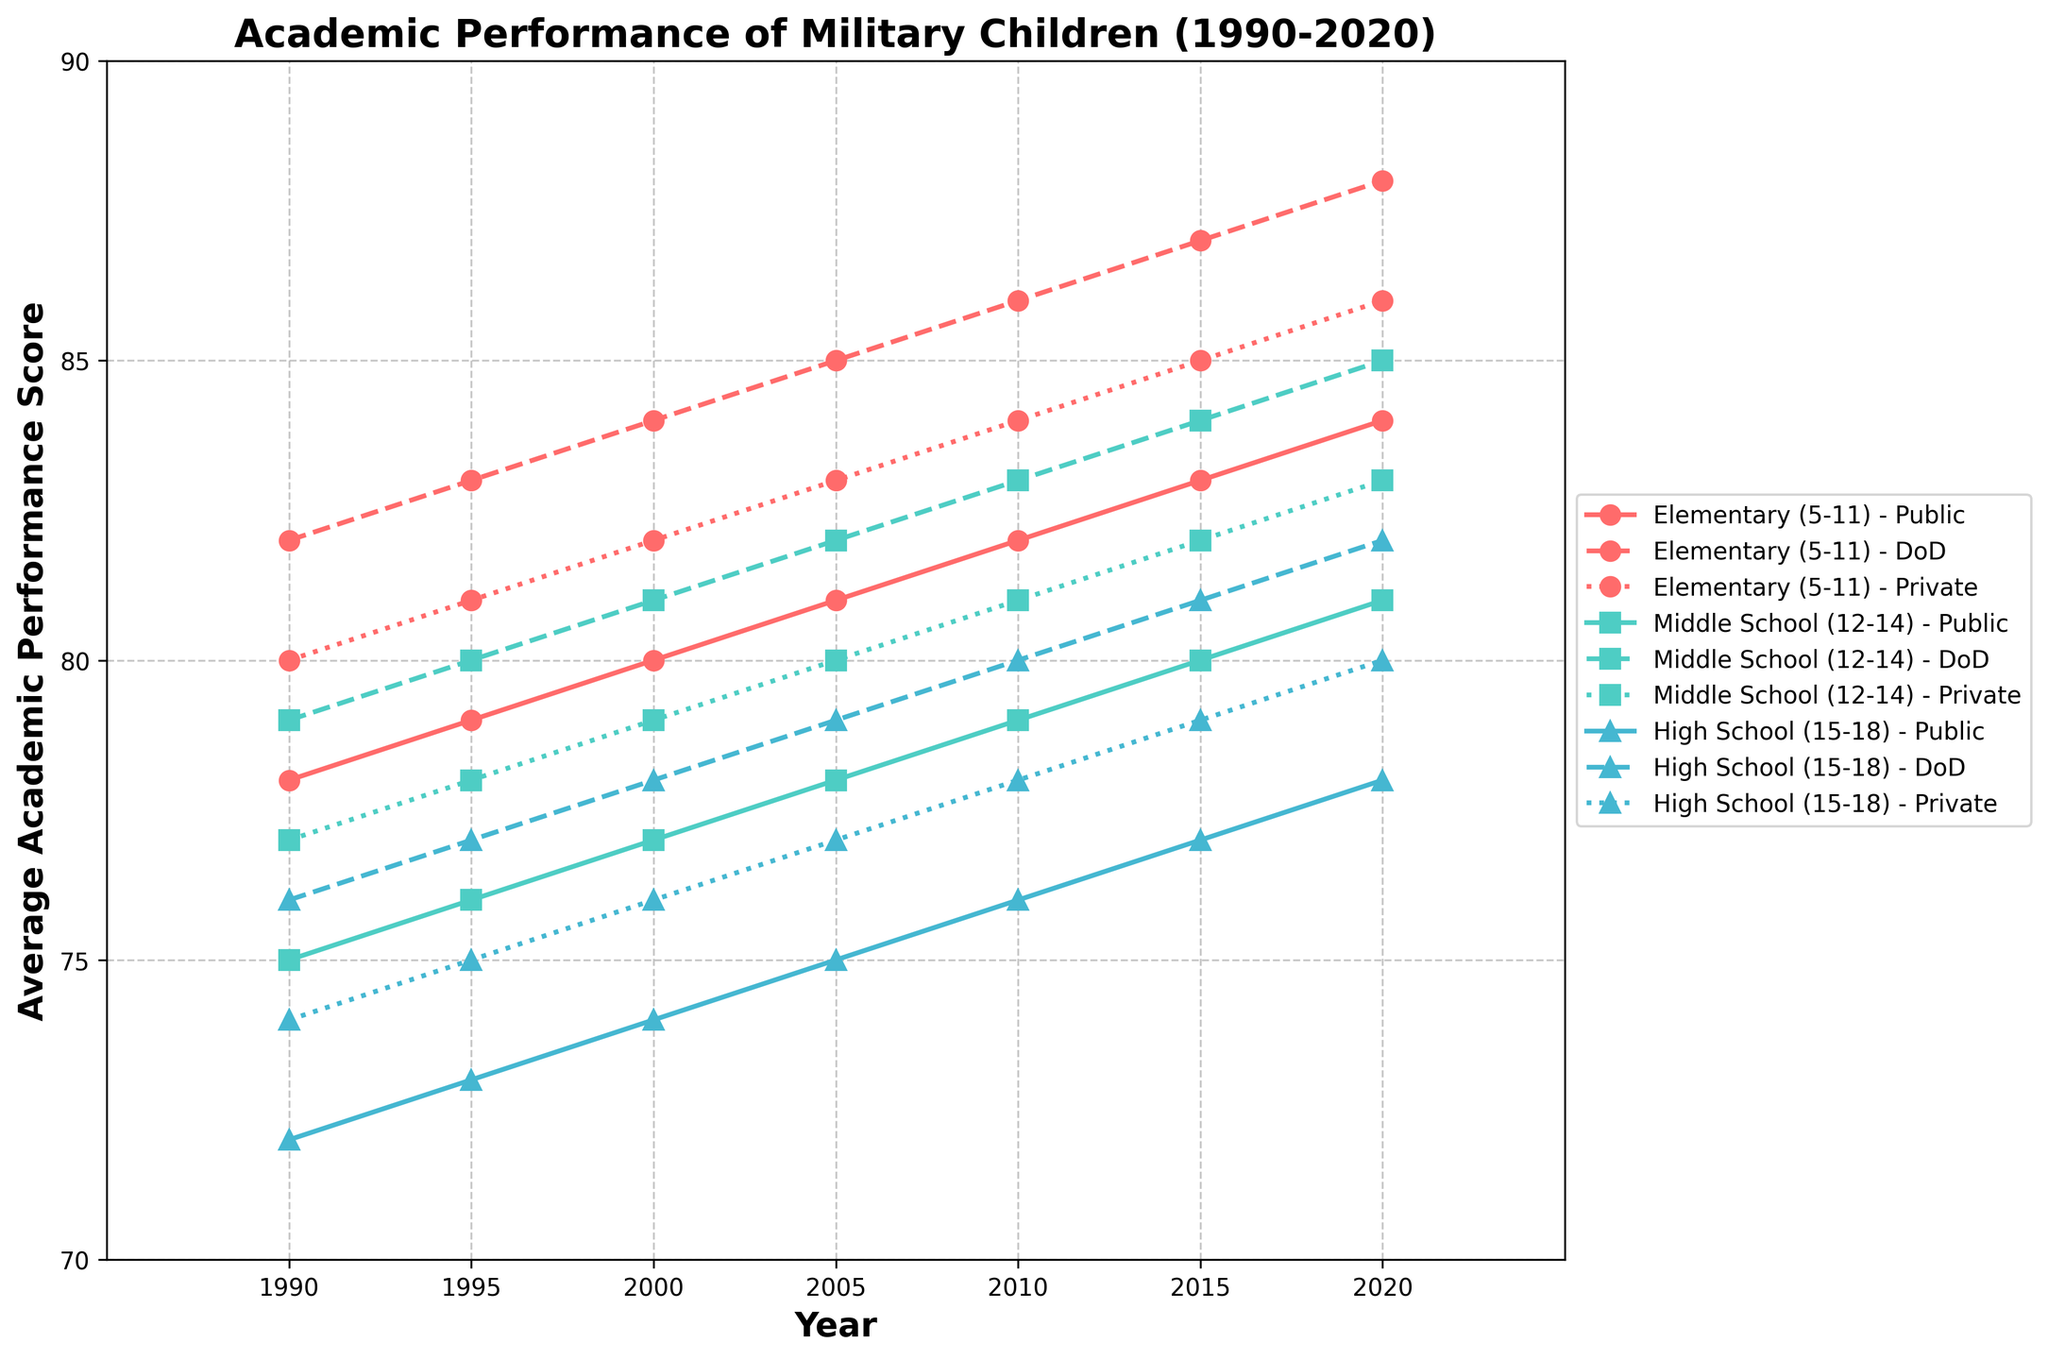which age group showed the highest average academic performance in 2020? First, locate the data points for 2020. Compare the scores for elementary (84), middle (81), and high school (78) across all school types. The highest value belongs to the elementary (5-11) age group.
Answer: Elementary (5-11) how did the performance of elementary (5-11) students in public schools change from 1990 to 2020? Look at the line corresponding to elementary students in public schools. In 1990, the score was 78, and in 2020, it increased to 84. The change is 84 - 78 = 6.
Answer: Increased by 6 points which school type had the most consistent performance improvement for high school students from 1990 to 2020? Examine the lines associated with high school students for public, DoD, and private schools. Each line shows improvement, but the public schools seem to have a steady upward trend from 72 to 78, indicating the most consistent improvement.
Answer: Public schools in 2010, which school type had the highest scores for middle school students? Check the data points for 2010 related to middle school students. Public schools scored 79, DoD schools scored 83, and private schools scored 81. The highest score is in DoD schools.
Answer: DoD schools what was the average score of elementary (5-11) students across all school types in 2010? For 2010, add the scores for public (82), DoD (86), and private schools (84). The sum is 82 + 86 + 84 = 252. Divide by the number of school types (3) to get the average: 252 / 3 = 84.
Answer: 84 compare the trend in performance for middle school (12-14) students in DoD schools versus private schools from 1990 to 2020. Observe the lines corresponding to DoD and private schools for middle school students. Both scores rise, with DoD schools starting from 79 and ending at 85, and private schools starting from 77 and ending at 83. Both show improvement, but DoD schools have higher starting and ending scores.
Answer: DoD schools had higher scores what is the difference in scores between public and DoD schools for high school students in 2015? Identify the scores for public (77) and DoD schools (81) in 2015 for high school students. Calculate the difference: 81 - 77 = 4.
Answer: 4 which visual attribute helps distinguish DoD schools' performance trends compared to public and private schools? The dotted line pattern is specifically used for representing DoD schools, helping to visually separate their trends from public (solid line) and private (dashed line) schools.
Answer: Dotted lines do elementary (5-11) students in private schools consistently outperform those in public schools from 1990 to 2020? Compare the lines for elementary students in public and private schools year by year. In each year, private schools' scores (80, 81, 82, 83, 84, 85, 86) are consistently higher than public schools' scores (78, 79, 80, 81, 82, 83, 84).
Answer: Yes 